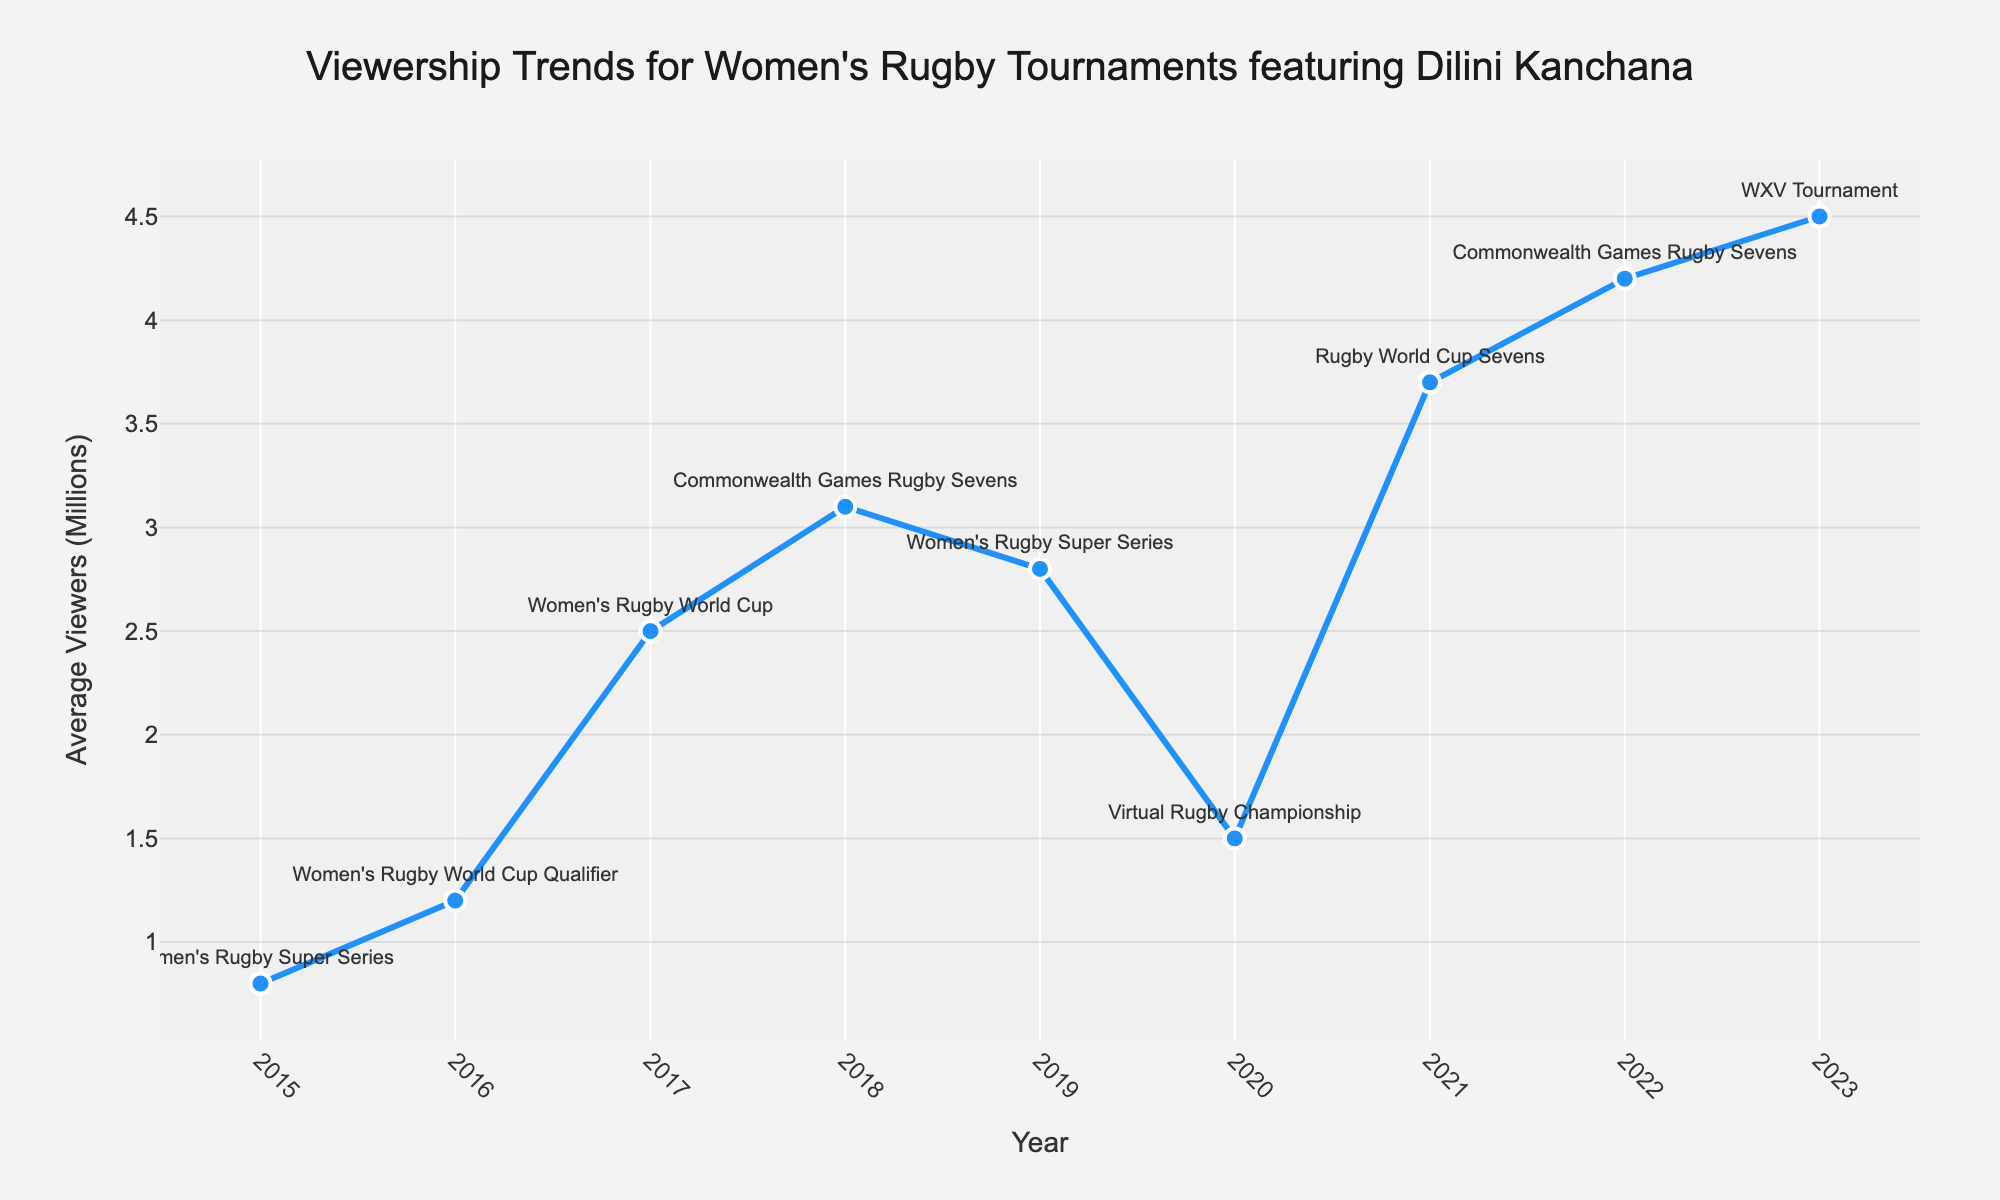What was the viewership for the Women's Rugby World Cup in 2017? According to the figure, the viewership for the Women's Rugby World Cup in 2017 is shown as 2.5 million viewers.
Answer: 2.5 million Which tournament had the highest average viewership? Observing the peaks in the line chart, the tournament with the highest average viewership is the WXV Tournament in 2023 with 4.5 million viewers.
Answer: WXV Tournament in 2023 How much did the viewership increase from the Women's Rugby Super Series in 2015 to the Commonwealth Games Rugby Sevens in 2022? The viewership for the Women's Rugby Super Series in 2015 was 0.8 million, and it rose to 4.2 million for the Commonwealth Games Rugby Sevens in 2022. The increase is 4.2 - 0.8 = 3.4 million viewers.
Answer: 3.4 million Which tournament had a lower viewership: the Commonwealth Games Rugby Sevens in 2018 or the Virtual Rugby Championship in 2020? Comparing the data points on the figure, the Commonwealth Games Rugby Sevens in 2018 had 3.1 million viewers, whereas the Virtual Rugby Championship in 2020 had 1.5 million viewers. The Virtual Rugby Championship in 2020 had a lower viewership.
Answer: Virtual Rugby Championship in 2020 What is the average viewership across all tournaments? To find the average viewership, sum all viewership numbers and divide by the number of years. (0.8 + 1.2 + 2.5 + 3.1 + 2.8 + 1.5 + 3.7 + 4.2 + 4.5) / 9 = 24.3 / 9 ≈ 2.7 million viewers.
Answer: 2.7 million What was the trend in viewership for the Women's Rugby Super Series from 2015 to 2019? The viewership for the Women's Rugby Super Series in 2015 was 0.8 million, and in 2019 it increased to 2.8 million. This indicates an increasing trend in viewership over these years.
Answer: Increasing trend How did viewership change from the Women's Rugby World Cup in 2017 to the Rugby World Cup Sevens in 2021? The viewership for the Women's Rugby World Cup in 2017 was 2.5 million, and it increased to 3.7 million for the Rugby World Cup Sevens in 2021. The change is 3.7 - 2.5 = 1.2 million viewers.
Answer: 1.2 million What was the viewership difference between the Women's Rugby World Cup Qualifier in 2016 and the Virtual Rugby Championship in 2020? The viewership for the Women's Rugby World Cup Qualifier in 2016 was 1.2 million and for the Virtual Rugby Championship in 2020 it was 1.5 million. The difference is 1.5 - 1.2 = 0.3 million viewers.
Answer: 0.3 million Which tournament immediately followed the Women's Rugby Super Series in 2019 in terms of viewership timeline? Looking at the progression of years on the x-axis, the Virtual Rugby Championship in 2020 immediately follows the Women's Rugby Super Series in 2019.
Answer: Virtual Rugby Championship in 2020 